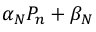Convert formula to latex. <formula><loc_0><loc_0><loc_500><loc_500>\alpha _ { N } P _ { n } + \beta _ { N }</formula> 